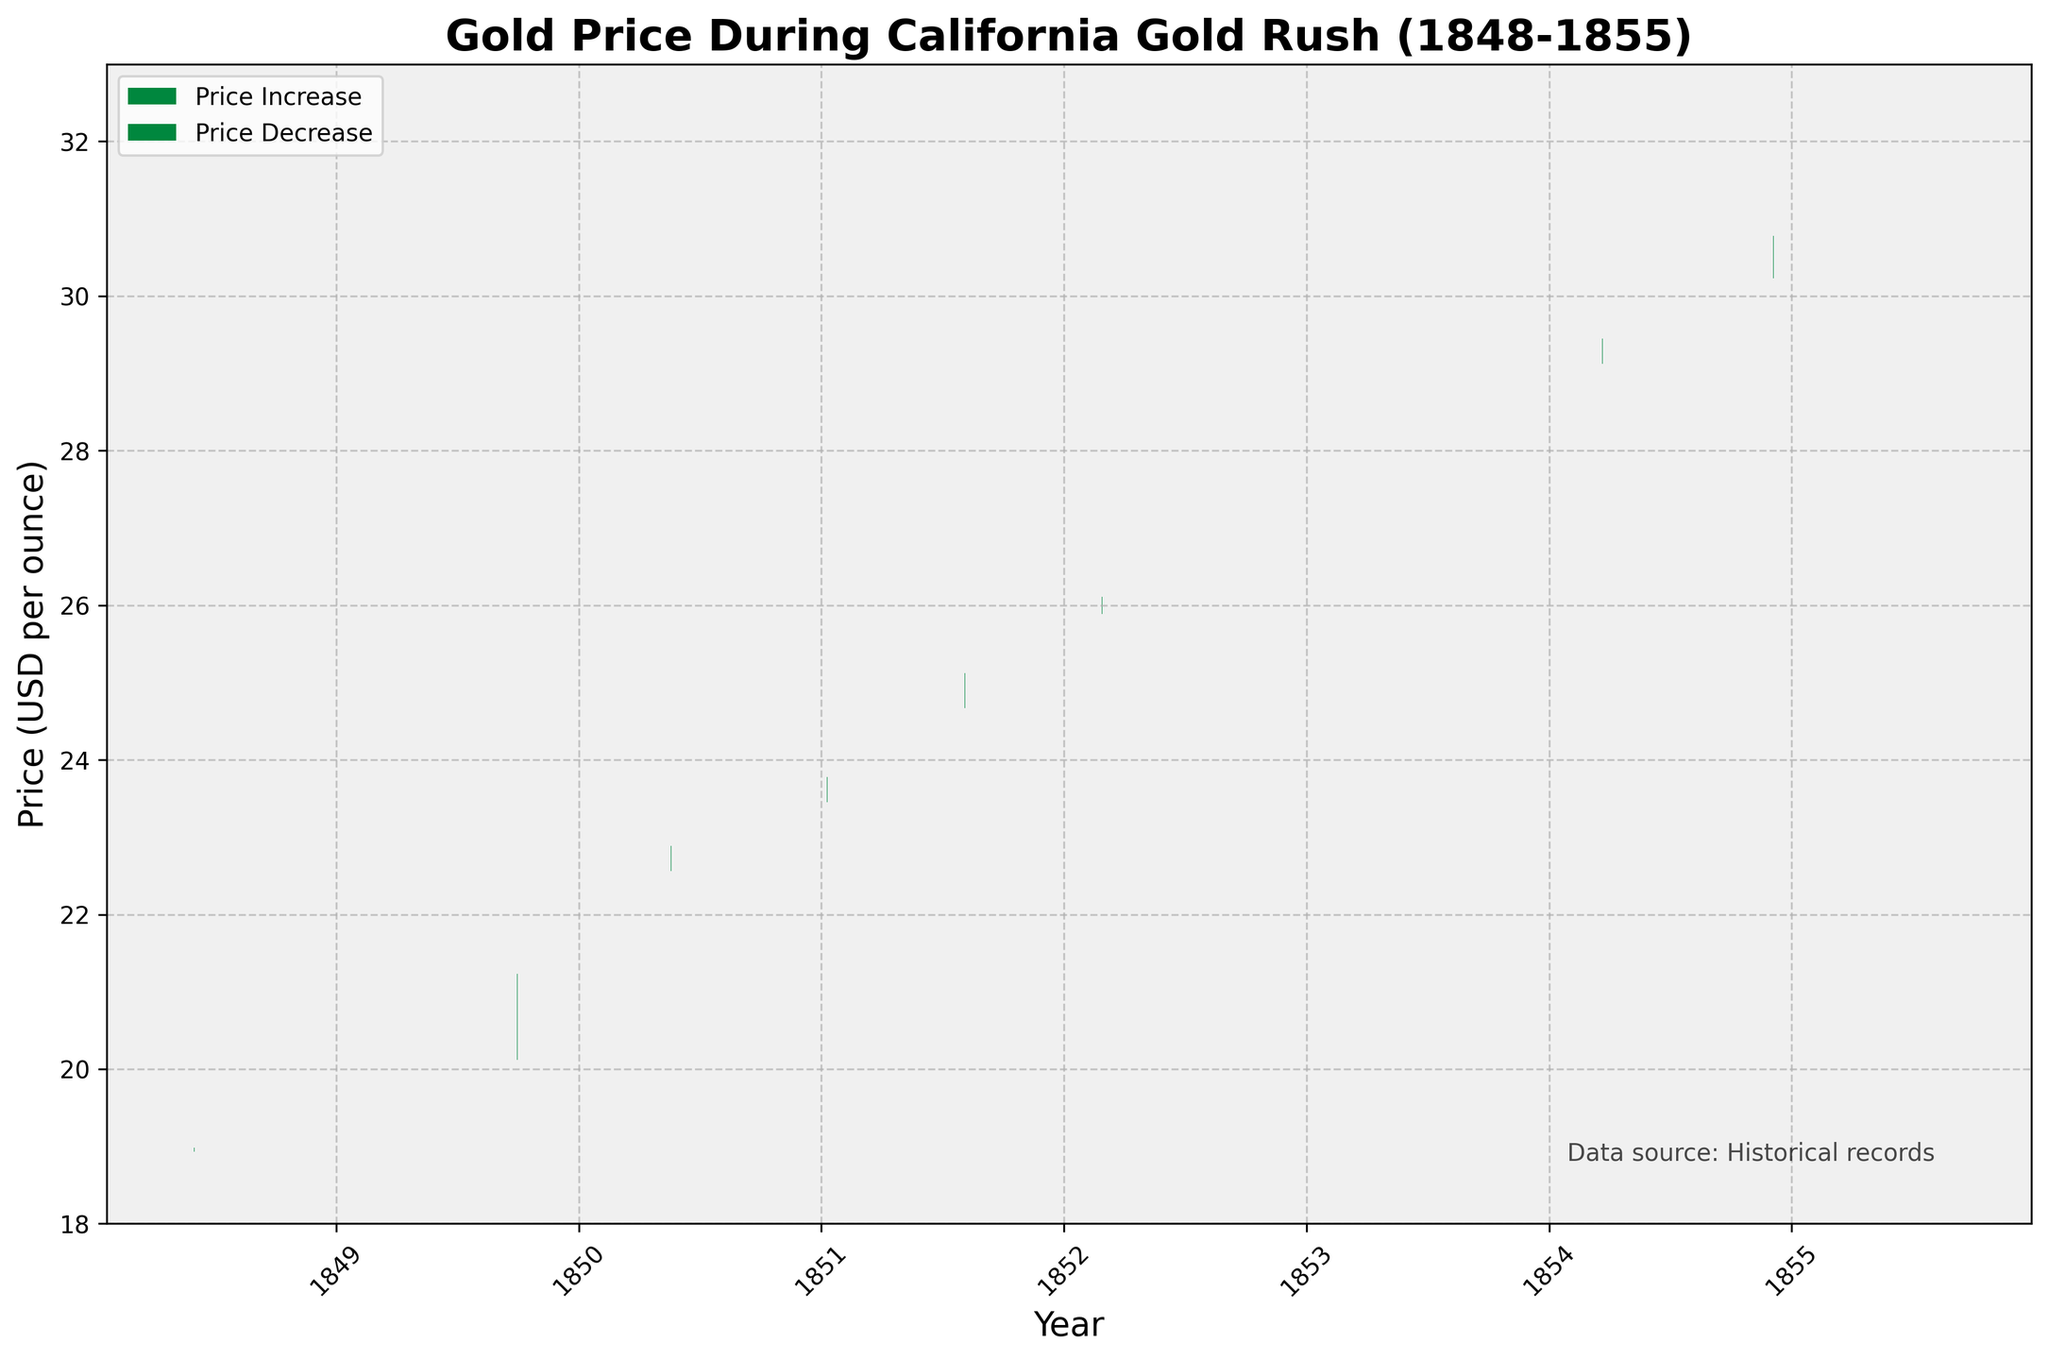What is the title of the plot? The title of the plot is located at the top center of the figure. It reads "Gold Price During California Gold Rush (1848-1855)"
Answer: Gold Price During California Gold Rush (1848-1855) What is the price on 1851-08-05 at market close? Look for the bar corresponding to the date 1851-08-05. The top or bottom of the bar tells the closing price, depending on whether the price increased or decreased.
Answer: 25.12 How many data points show an increase in gold price? To determine the number of price increases, count the number of green bars, which represent an increase in price from open to close.
Answer: 9 When did the gold price reach its highest level and what was that price? Check for the highest point of the bars, focusing on the green and red bars' tops. The highest value should be on 1855-08-18 at 32.18
Answer: 1855-08-18, 32.18 What is the average closing price of gold in the data given? Sum all the closing prices and divide by the number of data points. Sum = 18.98 + 19.65 + 21.23 + 22.89 + 23.78 + 25.12 + 26.11 + 27.21 + 28.34 + 29.45 + 30.78 + 31.89 = 305.43; there are 12 data points, so the average is 305.43 / 12
Answer: 25.45 Which date recorded the largest daily fluctuation (difference between high and low), and what was the fluctuation amount? For each date, subtract the low from the high to find the fluctuation and then find the date with the largest result. The largest fluctuation is on 1854-12-05, with a high of 31.05 and low of 29.98; fluctuation is 31.05 - 29.98 = 1.07
Answer: 1854-12-05, 1.07 How did the gold price change from the beginning to the end of the data period (1848-06-01 to 1855-08-18)? Compare the opening price on 1848-06-01 (18.93) to the closing price on 1855-08-18 (31.89).
Answer: Increased by 12.96 Which month and year saw the highest closing price during the California Gold Rush? Scan the closing prices to find the highest value and its corresponding date; the highest closing price is on 1855-08-18 at 31.89.
Answer: August 1855, 31.89 What is the trend in gold prices from 1852-02-28 to 1854-03-22? Observe the closing prices from 1852-02-28 (26.11) to 1854-03-22 (29.45) and identify the trend.
Answer: Upward trend 